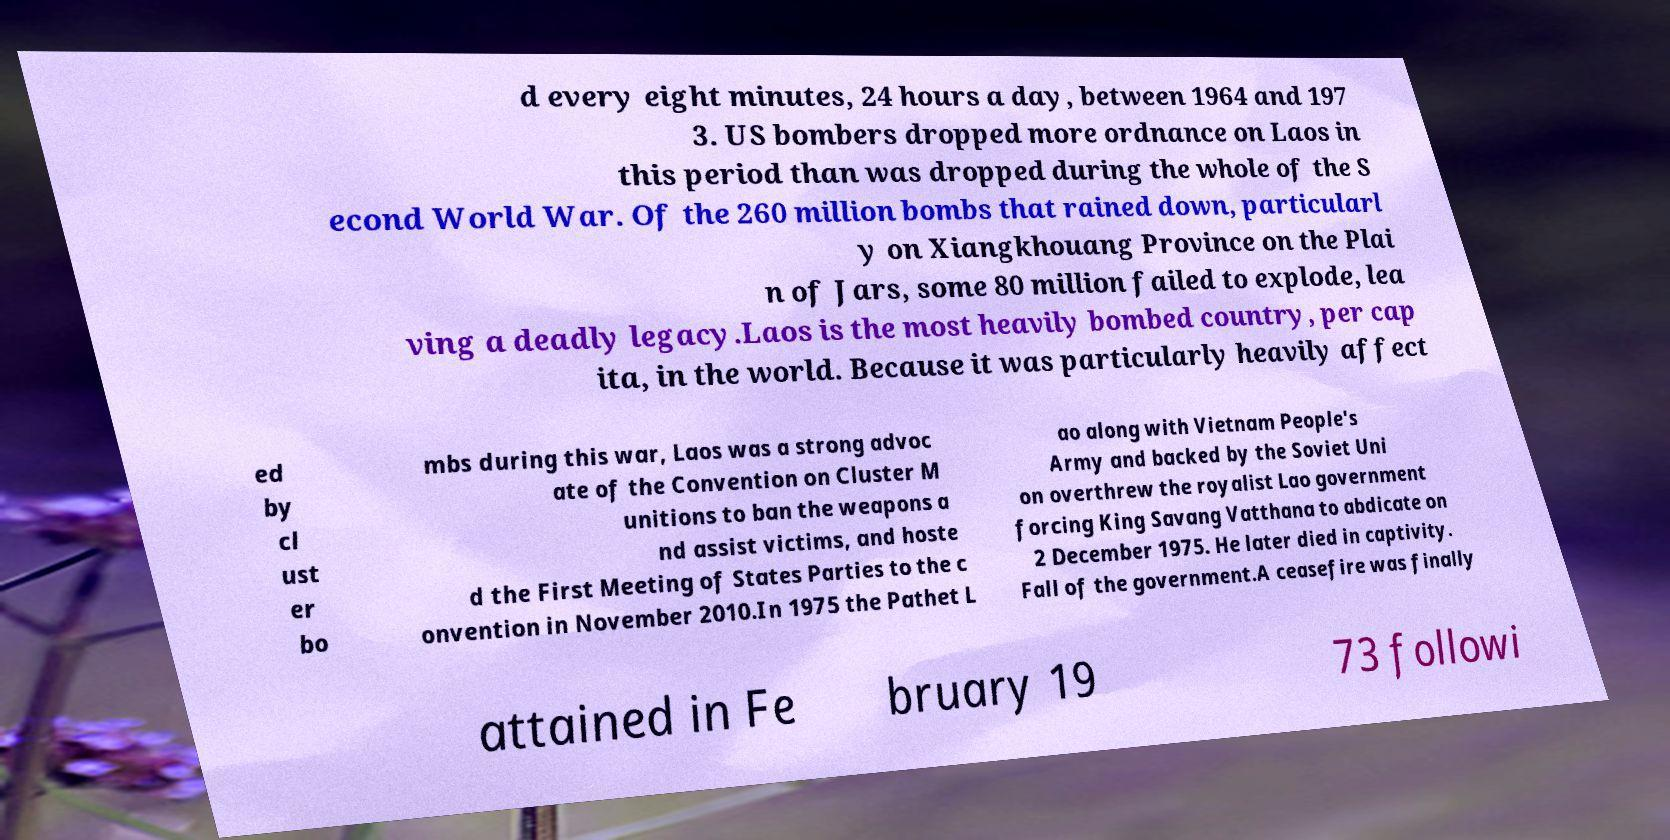Please read and relay the text visible in this image. What does it say? d every eight minutes, 24 hours a day, between 1964 and 197 3. US bombers dropped more ordnance on Laos in this period than was dropped during the whole of the S econd World War. Of the 260 million bombs that rained down, particularl y on Xiangkhouang Province on the Plai n of Jars, some 80 million failed to explode, lea ving a deadly legacy.Laos is the most heavily bombed country, per cap ita, in the world. Because it was particularly heavily affect ed by cl ust er bo mbs during this war, Laos was a strong advoc ate of the Convention on Cluster M unitions to ban the weapons a nd assist victims, and hoste d the First Meeting of States Parties to the c onvention in November 2010.In 1975 the Pathet L ao along with Vietnam People's Army and backed by the Soviet Uni on overthrew the royalist Lao government forcing King Savang Vatthana to abdicate on 2 December 1975. He later died in captivity. Fall of the government.A ceasefire was finally attained in Fe bruary 19 73 followi 